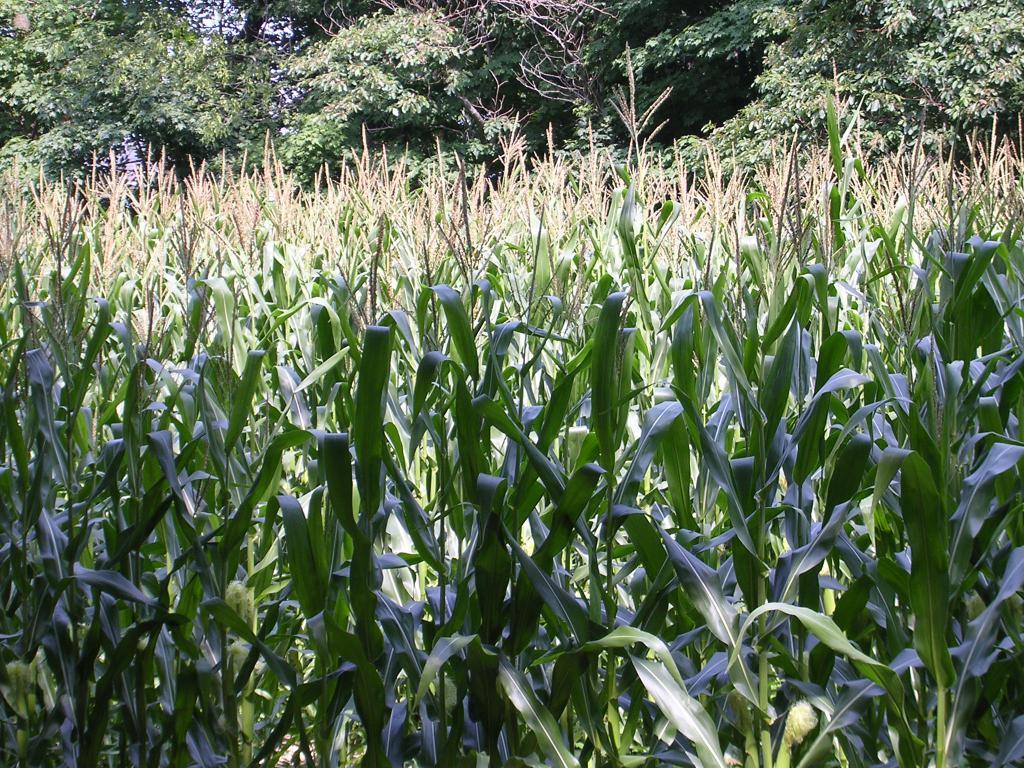What type of vegetation can be seen in the image? There are plants and trees in the image. What is visible at the top of the image? The sky is visible at the top of the image. What type of jeans can be seen hanging on the tree in the image? There are no jeans present in the image; it features plants, trees, and the sky. 